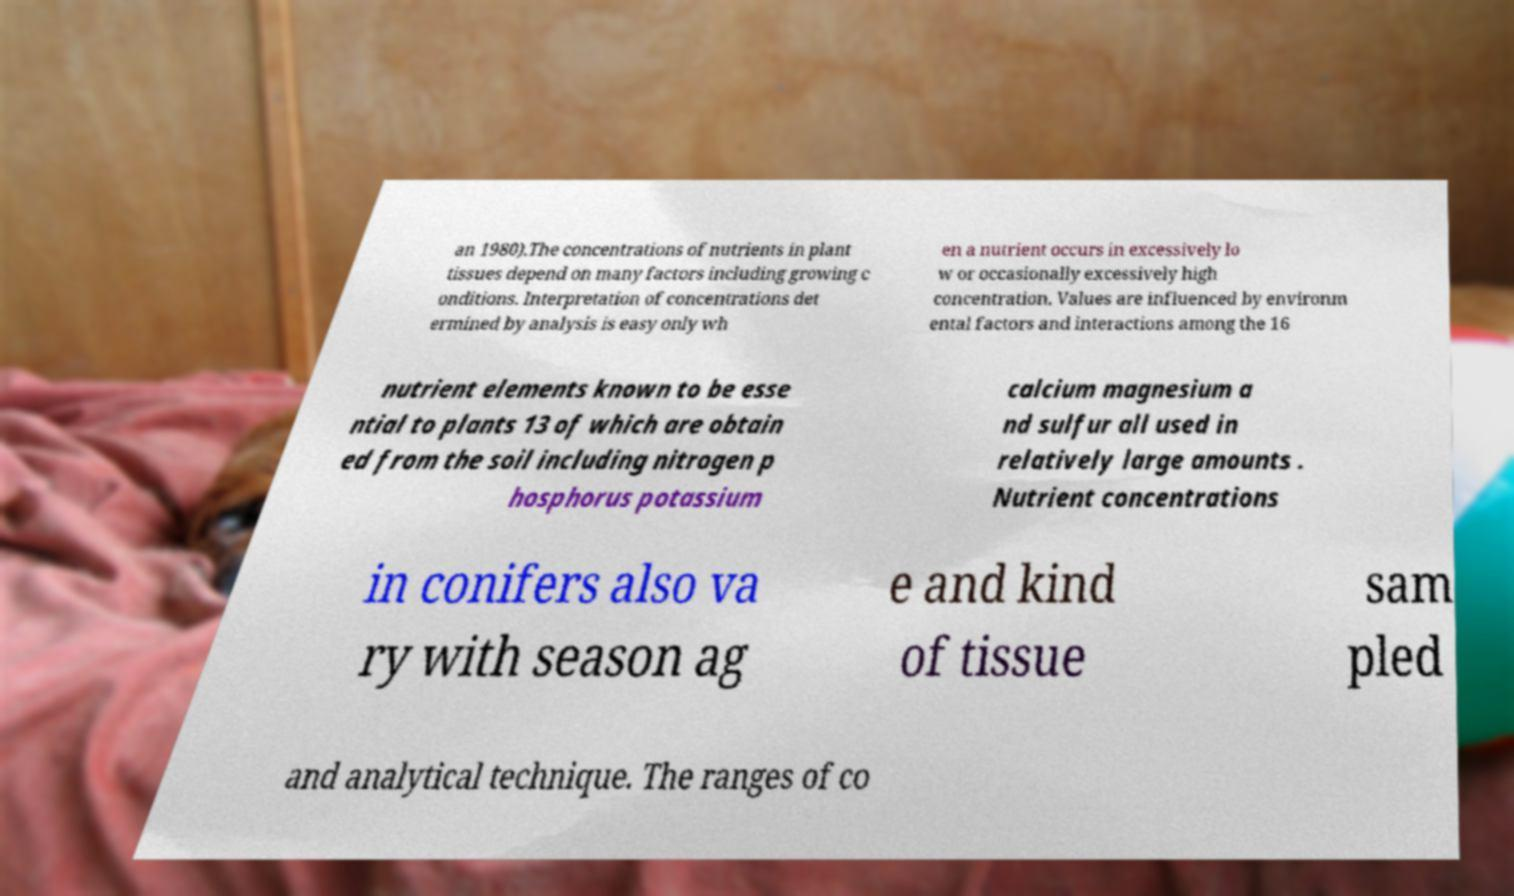I need the written content from this picture converted into text. Can you do that? an 1980).The concentrations of nutrients in plant tissues depend on many factors including growing c onditions. Interpretation of concentrations det ermined by analysis is easy only wh en a nutrient occurs in excessively lo w or occasionally excessively high concentration. Values are influenced by environm ental factors and interactions among the 16 nutrient elements known to be esse ntial to plants 13 of which are obtain ed from the soil including nitrogen p hosphorus potassium calcium magnesium a nd sulfur all used in relatively large amounts . Nutrient concentrations in conifers also va ry with season ag e and kind of tissue sam pled and analytical technique. The ranges of co 